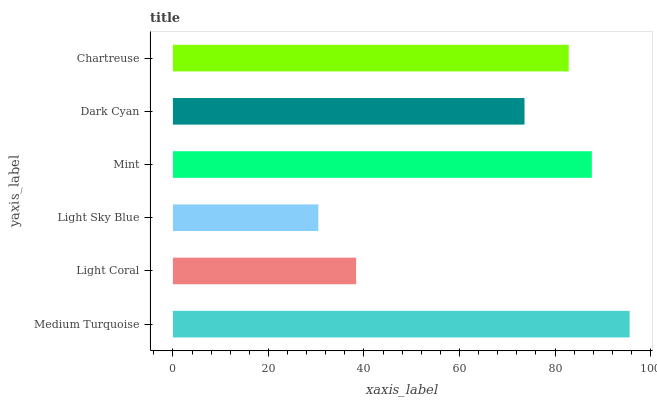Is Light Sky Blue the minimum?
Answer yes or no. Yes. Is Medium Turquoise the maximum?
Answer yes or no. Yes. Is Light Coral the minimum?
Answer yes or no. No. Is Light Coral the maximum?
Answer yes or no. No. Is Medium Turquoise greater than Light Coral?
Answer yes or no. Yes. Is Light Coral less than Medium Turquoise?
Answer yes or no. Yes. Is Light Coral greater than Medium Turquoise?
Answer yes or no. No. Is Medium Turquoise less than Light Coral?
Answer yes or no. No. Is Chartreuse the high median?
Answer yes or no. Yes. Is Dark Cyan the low median?
Answer yes or no. Yes. Is Medium Turquoise the high median?
Answer yes or no. No. Is Light Coral the low median?
Answer yes or no. No. 